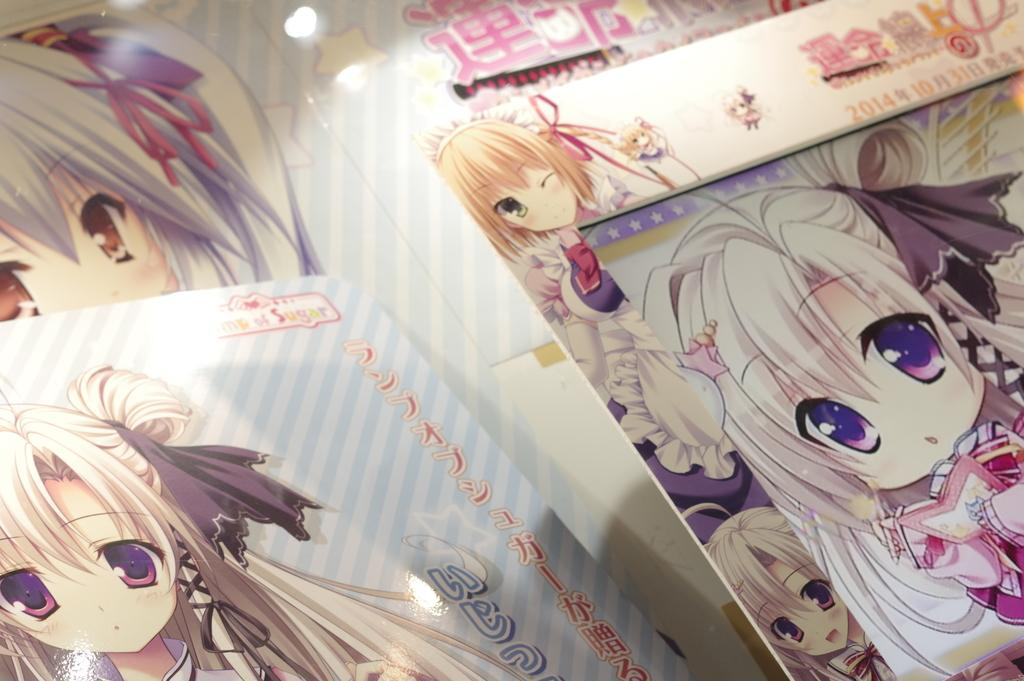What object can be seen on the right side of the image? There is a photo frame on the right side of the image. What is inside the photo frame? The photo frame contains an animated image. What can be seen on the left side of the image? There is an animated character on the left side of the image. What color is the creature that is sailing in the vessel in the image? There is no creature or vessel present in the image; it features a photo frame with an animated image and an animated character. 